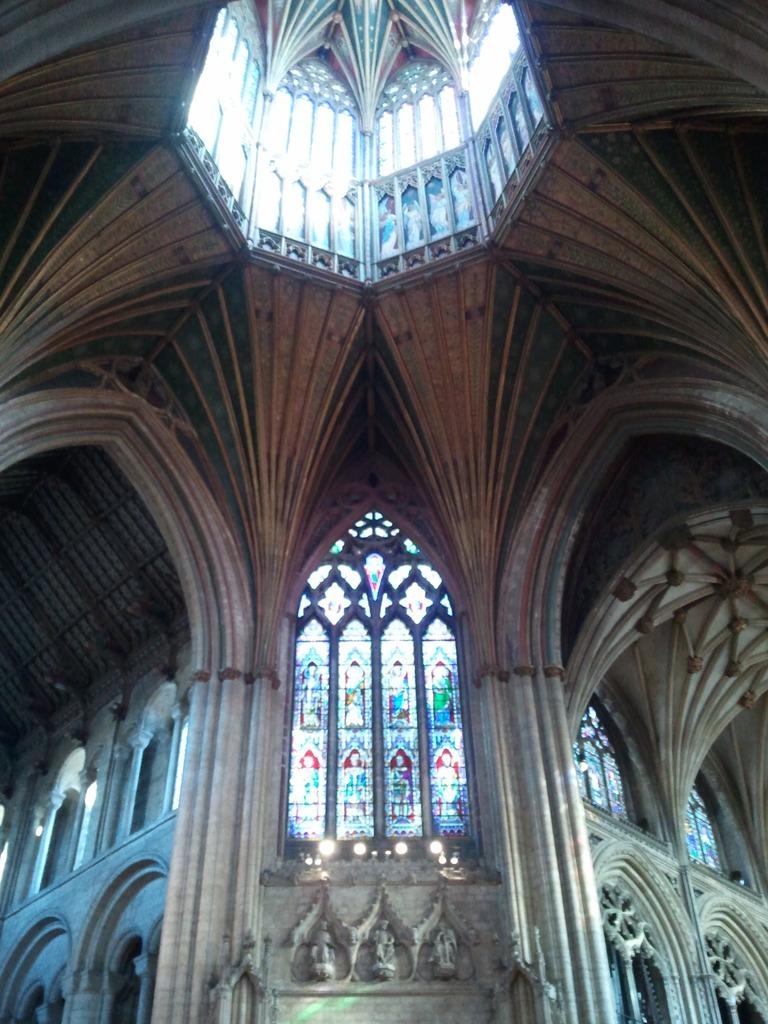What is the perspective of the image? The image is a view from inside a building. What type of windows are present in the image? There are glass windows in the image. What decorative elements can be seen on the windows? There are paintings on the glass windows. What type of quince is being used as a decoration in the image? There is no quince present in the image; it features glass windows with paintings on them. Can you see a fire hydrant outside the building in the image? There is no fire hydrant visible in the image, as it is focused on the view from inside the building. 